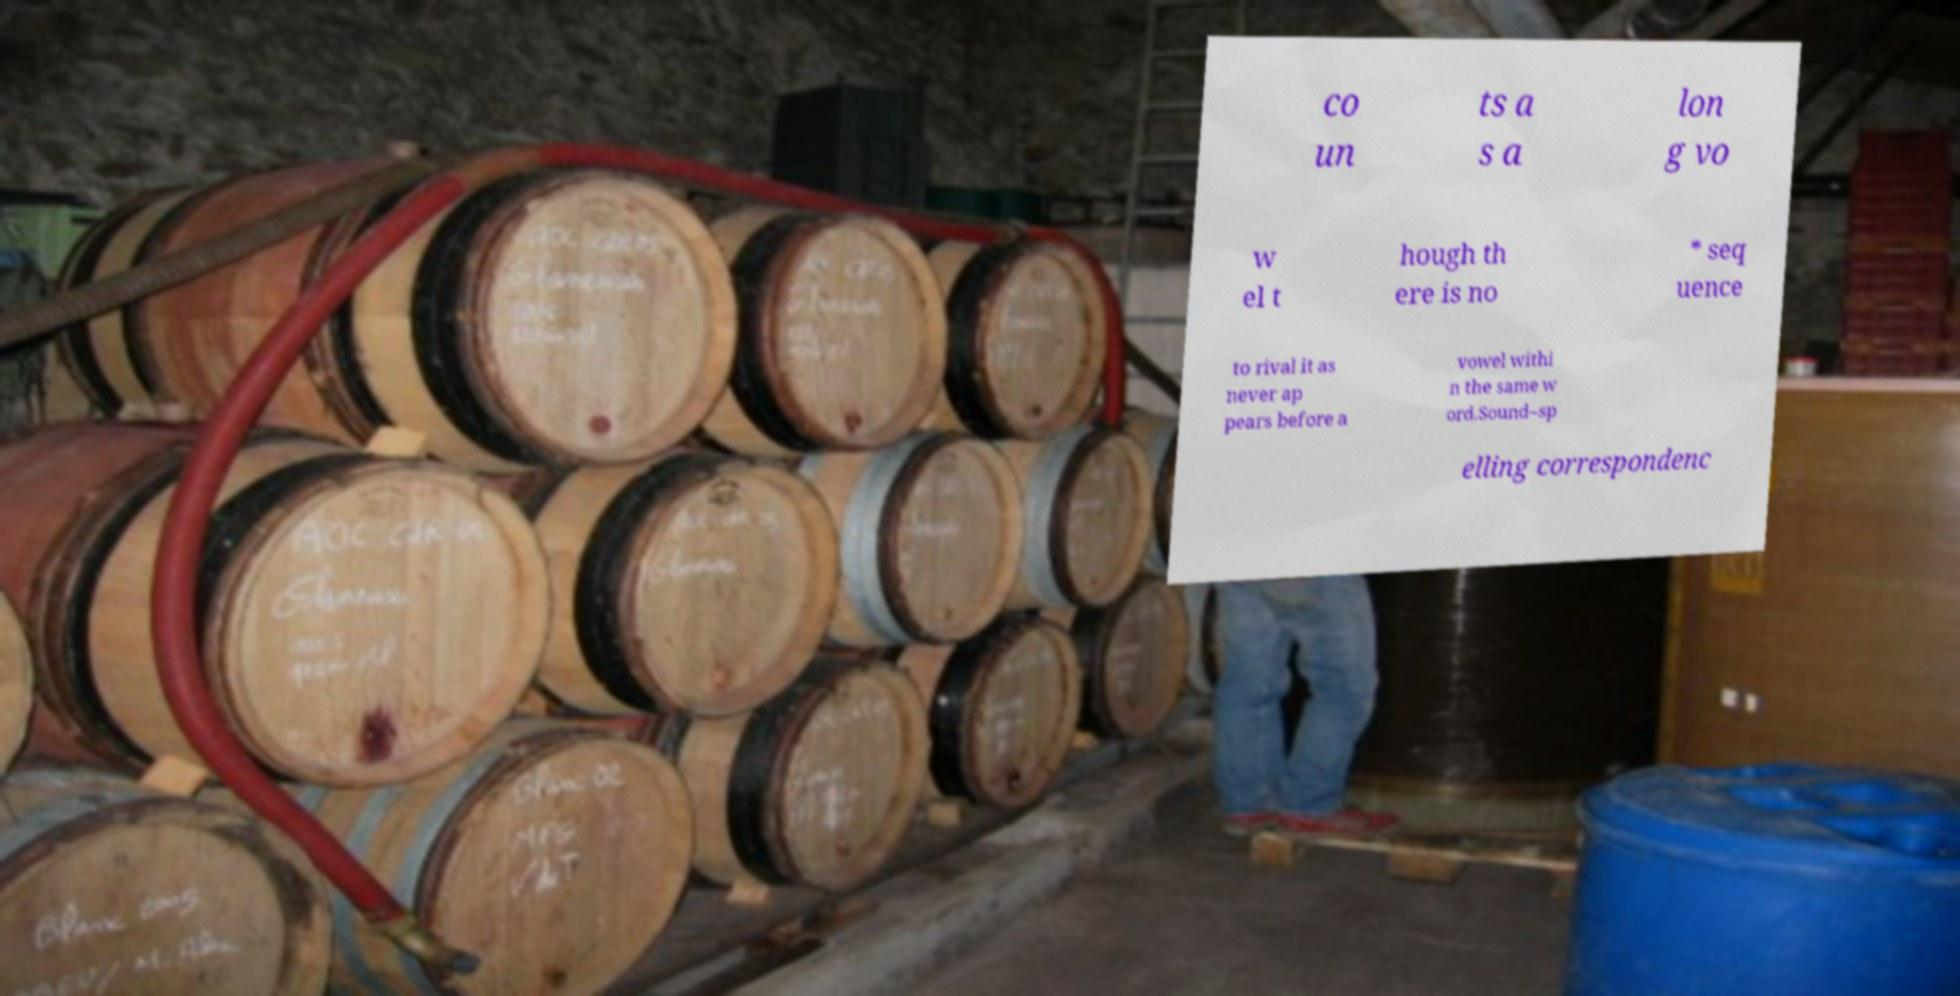Can you accurately transcribe the text from the provided image for me? co un ts a s a lon g vo w el t hough th ere is no * seq uence to rival it as never ap pears before a vowel withi n the same w ord.Sound–sp elling correspondenc 